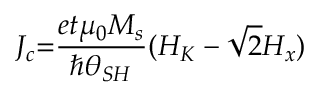Convert formula to latex. <formula><loc_0><loc_0><loc_500><loc_500>J _ { c } { = } \frac { e t { \mu } _ { 0 } M _ { s } } { \hslash { \theta } _ { S H } } ( H _ { K } - \sqrt { 2 } H _ { x } )</formula> 